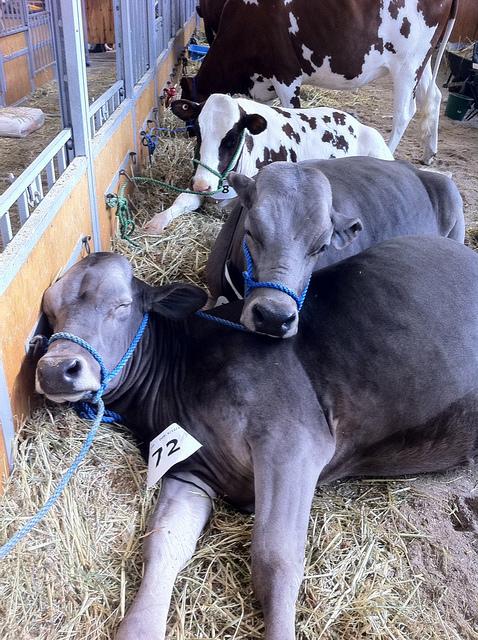How many cows are in this picture?
Keep it brief. 4. Why would the cow have a number?
Give a very brief answer. Identification. What color is the rope on the spotted cow's head?
Concise answer only. Blue. 